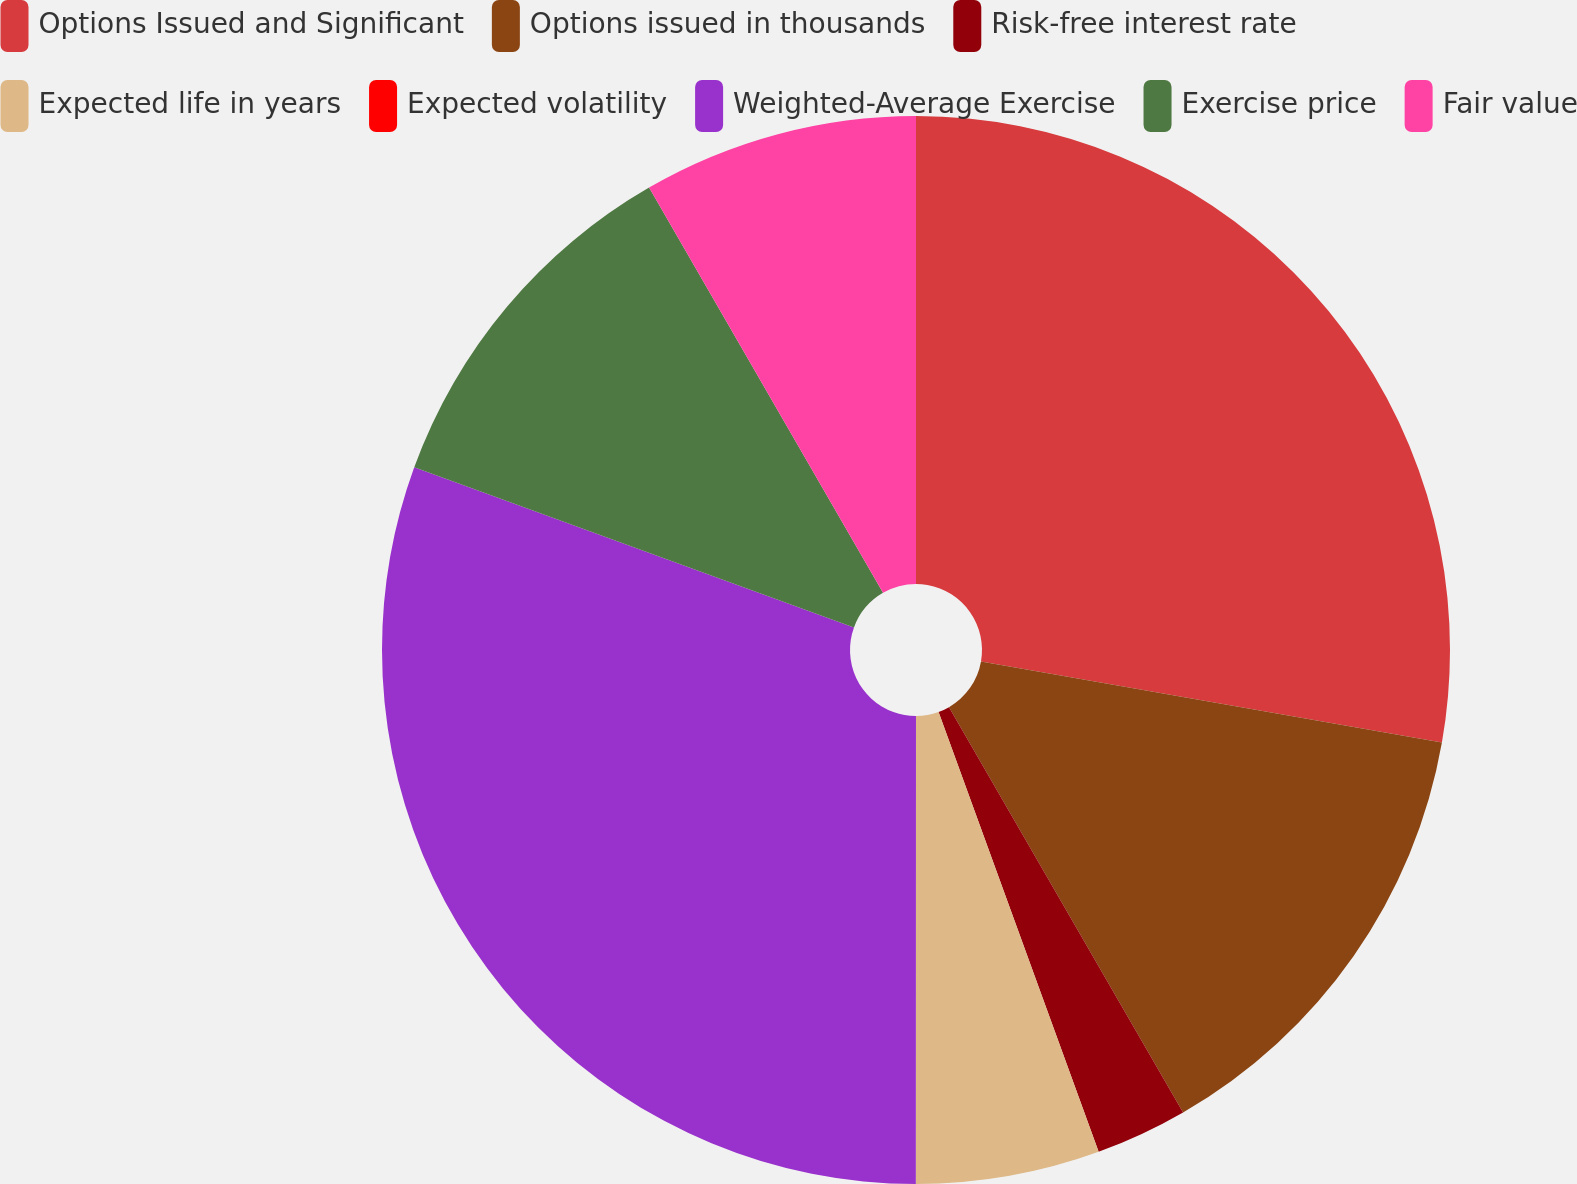Convert chart. <chart><loc_0><loc_0><loc_500><loc_500><pie_chart><fcel>Options Issued and Significant<fcel>Options issued in thousands<fcel>Risk-free interest rate<fcel>Expected life in years<fcel>Expected volatility<fcel>Weighted-Average Exercise<fcel>Exercise price<fcel>Fair value<nl><fcel>27.77%<fcel>13.89%<fcel>2.78%<fcel>5.56%<fcel>0.0%<fcel>30.55%<fcel>11.11%<fcel>8.33%<nl></chart> 